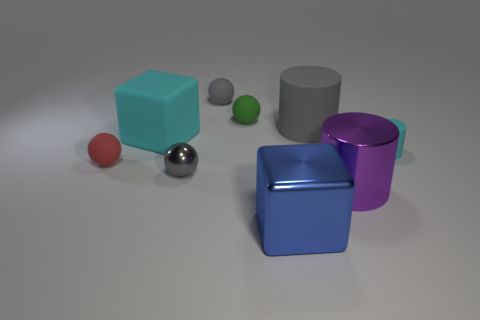Are there any small green cylinders? Yes, there is one small green cylinder located to the right of the gray cylinder. 